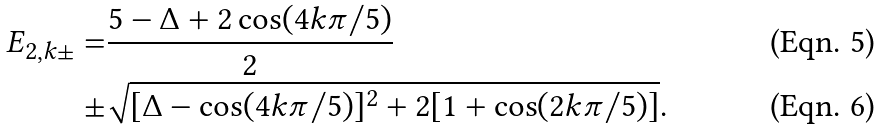Convert formula to latex. <formula><loc_0><loc_0><loc_500><loc_500>E _ { 2 , k \pm } = & \frac { 5 - \Delta + 2 \cos ( 4 k \pi / 5 ) } { 2 } \\ \pm & \sqrt { [ \Delta - \cos ( 4 k \pi / 5 ) ] ^ { 2 } + 2 [ 1 + \cos ( 2 k \pi / 5 ) ] } .</formula> 